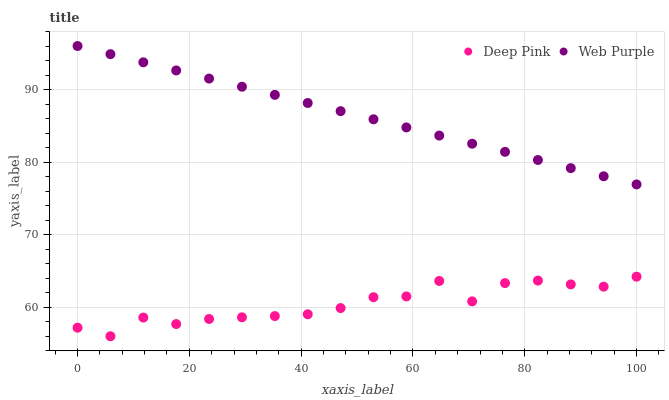Does Deep Pink have the minimum area under the curve?
Answer yes or no. Yes. Does Web Purple have the maximum area under the curve?
Answer yes or no. Yes. Does Deep Pink have the maximum area under the curve?
Answer yes or no. No. Is Web Purple the smoothest?
Answer yes or no. Yes. Is Deep Pink the roughest?
Answer yes or no. Yes. Is Deep Pink the smoothest?
Answer yes or no. No. Does Deep Pink have the lowest value?
Answer yes or no. Yes. Does Web Purple have the highest value?
Answer yes or no. Yes. Does Deep Pink have the highest value?
Answer yes or no. No. Is Deep Pink less than Web Purple?
Answer yes or no. Yes. Is Web Purple greater than Deep Pink?
Answer yes or no. Yes. Does Deep Pink intersect Web Purple?
Answer yes or no. No. 